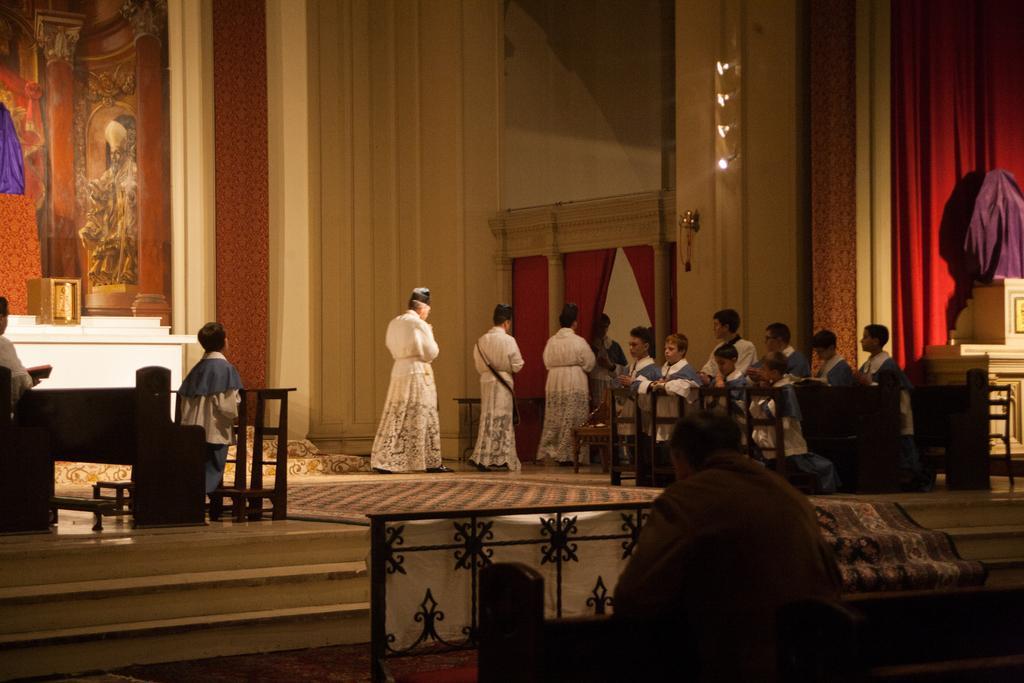Could you give a brief overview of what you see in this image? In this image there are a few people walking on the stage and there is a child, in front of the child there is a wooden structure, behind him there is a person sitting and holding a book on the bench. On the other side of the image there are a few children, in front of them there is a wooden structure. In the background there is a wall with paintings and some curtains. At the bottom of the image there is a person, in front of the person there is a railing, beside the railing there are stairs and there is a carpet on the stairs. 